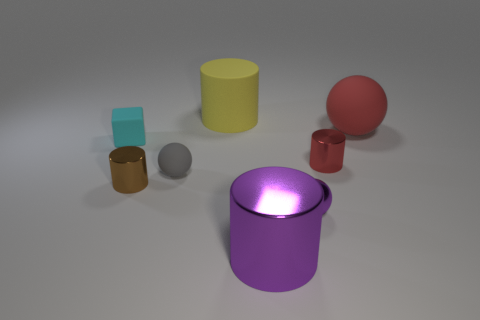Do the gray matte thing and the tiny red metallic thing have the same shape?
Your answer should be very brief. No. There is a rubber object that is right of the large object that is behind the red ball; what shape is it?
Your response must be concise. Sphere. Are there any small cyan matte things?
Provide a short and direct response. Yes. There is a ball left of the large cylinder that is in front of the gray rubber object; what number of tiny things are in front of it?
Ensure brevity in your answer.  2. There is a large metallic object; is it the same shape as the big rubber object that is on the right side of the big metal cylinder?
Give a very brief answer. No. Is the number of large matte things greater than the number of purple rubber cubes?
Offer a very short reply. Yes. Does the shiny thing on the left side of the large matte cylinder have the same shape as the tiny purple thing?
Your answer should be compact. No. Are there more spheres that are to the right of the tiny red cylinder than tiny purple shiny cylinders?
Your answer should be very brief. Yes. There is a small shiny cylinder that is to the left of the metal cylinder that is on the right side of the metal ball; what color is it?
Give a very brief answer. Brown. How many small cyan matte cubes are there?
Provide a short and direct response. 1. 